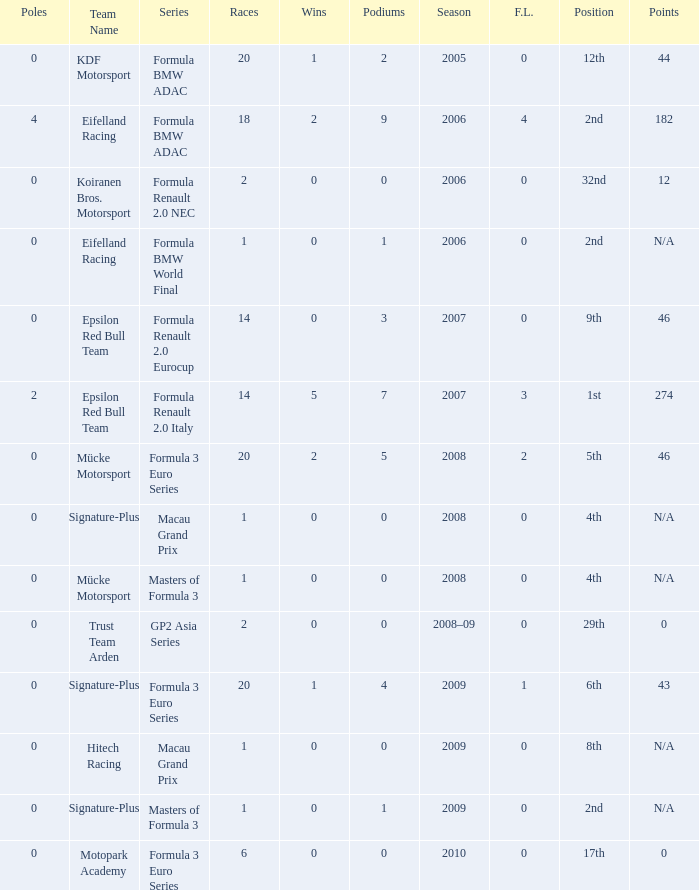What is the average number of podiums in the 32nd position with less than 0 wins? None. Can you give me this table as a dict? {'header': ['Poles', 'Team Name', 'Series', 'Races', 'Wins', 'Podiums', 'Season', 'F.L.', 'Position', 'Points'], 'rows': [['0', 'KDF Motorsport', 'Formula BMW ADAC', '20', '1', '2', '2005', '0', '12th', '44'], ['4', 'Eifelland Racing', 'Formula BMW ADAC', '18', '2', '9', '2006', '4', '2nd', '182'], ['0', 'Koiranen Bros. Motorsport', 'Formula Renault 2.0 NEC', '2', '0', '0', '2006', '0', '32nd', '12'], ['0', 'Eifelland Racing', 'Formula BMW World Final', '1', '0', '1', '2006', '0', '2nd', 'N/A'], ['0', 'Epsilon Red Bull Team', 'Formula Renault 2.0 Eurocup', '14', '0', '3', '2007', '0', '9th', '46'], ['2', 'Epsilon Red Bull Team', 'Formula Renault 2.0 Italy', '14', '5', '7', '2007', '3', '1st', '274'], ['0', 'Mücke Motorsport', 'Formula 3 Euro Series', '20', '2', '5', '2008', '2', '5th', '46'], ['0', 'Signature-Plus', 'Macau Grand Prix', '1', '0', '0', '2008', '0', '4th', 'N/A'], ['0', 'Mücke Motorsport', 'Masters of Formula 3', '1', '0', '0', '2008', '0', '4th', 'N/A'], ['0', 'Trust Team Arden', 'GP2 Asia Series', '2', '0', '0', '2008–09', '0', '29th', '0'], ['0', 'Signature-Plus', 'Formula 3 Euro Series', '20', '1', '4', '2009', '1', '6th', '43'], ['0', 'Hitech Racing', 'Macau Grand Prix', '1', '0', '0', '2009', '0', '8th', 'N/A'], ['0', 'Signature-Plus', 'Masters of Formula 3', '1', '0', '1', '2009', '0', '2nd', 'N/A'], ['0', 'Motopark Academy', 'Formula 3 Euro Series', '6', '0', '0', '2010', '0', '17th', '0']]} 